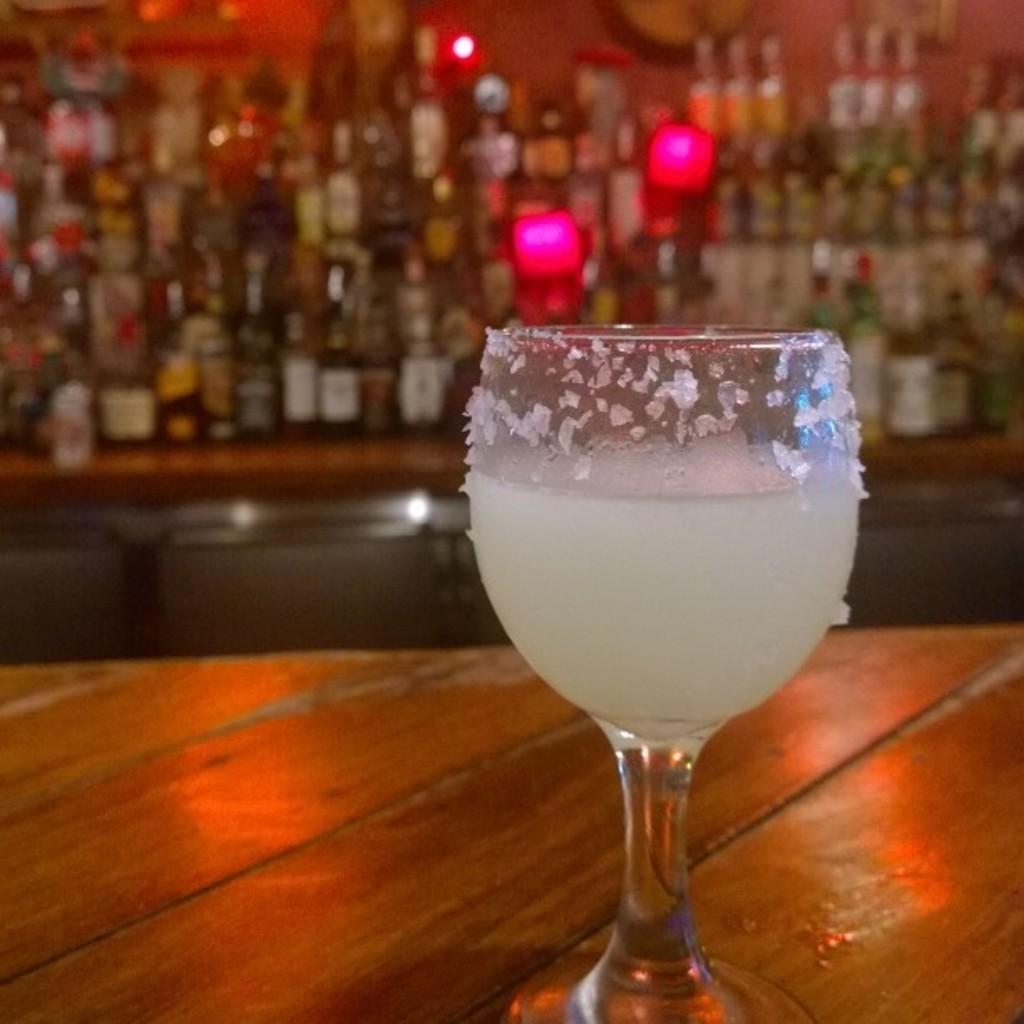Could you give a brief overview of what you see in this image? In this image we can see a glass with some liquid in it on the wooden surface. In the background of the image there are bottles arranged in a rack. 